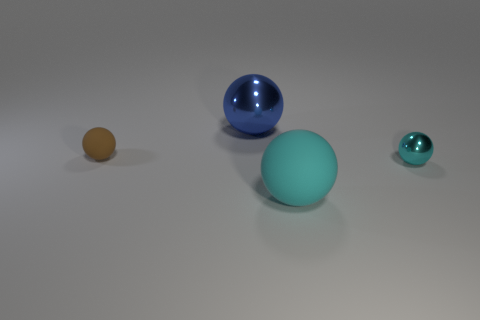Subtract all purple cubes. How many cyan balls are left? 2 Subtract all tiny brown rubber spheres. How many spheres are left? 3 Add 4 small green shiny balls. How many objects exist? 8 Subtract all yellow balls. Subtract all red cylinders. How many balls are left? 4 Subtract all tiny rubber cylinders. Subtract all spheres. How many objects are left? 0 Add 1 spheres. How many spheres are left? 5 Add 4 metal objects. How many metal objects exist? 6 Subtract 0 yellow cubes. How many objects are left? 4 